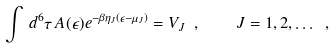<formula> <loc_0><loc_0><loc_500><loc_500>\int \, d ^ { 6 } \tau \, A ( \epsilon ) e ^ { - \beta \eta _ { J } ( \epsilon - \mu _ { J } ) } = V _ { J } \ , \quad J = 1 , 2 , \dots \ ,</formula> 